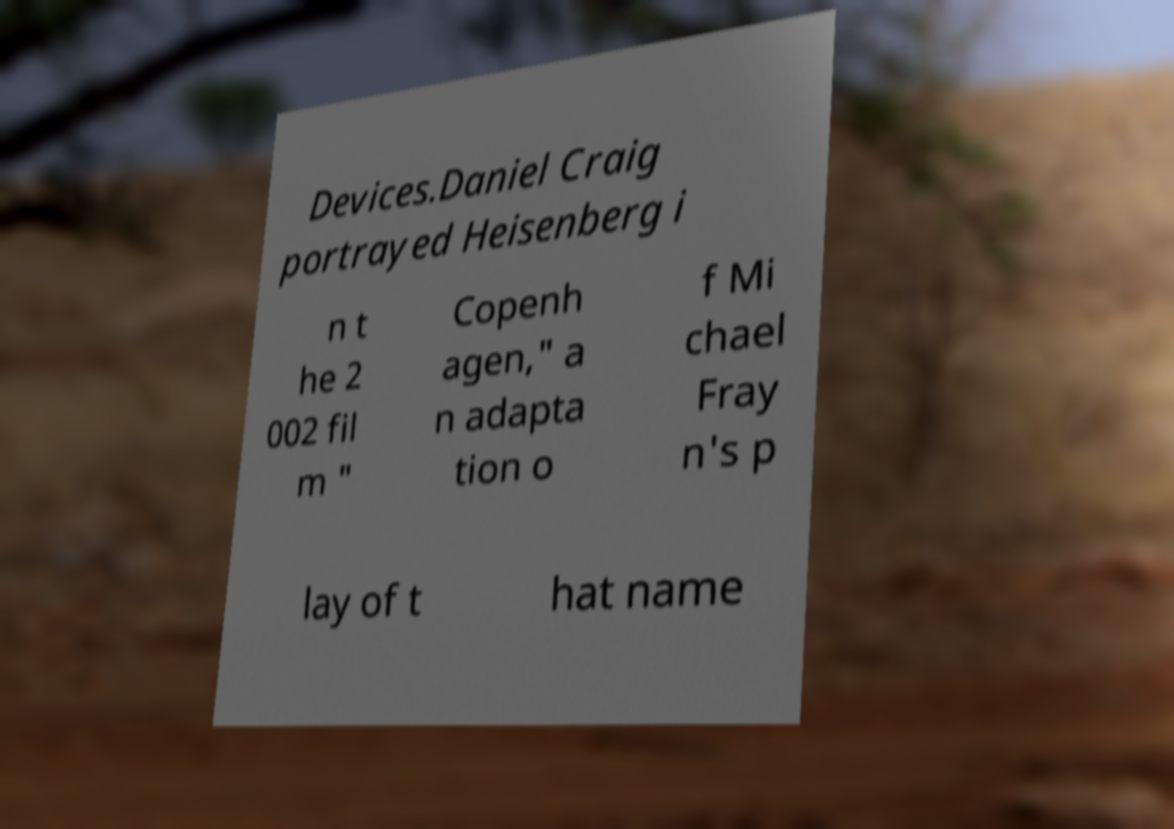Please read and relay the text visible in this image. What does it say? Devices.Daniel Craig portrayed Heisenberg i n t he 2 002 fil m " Copenh agen," a n adapta tion o f Mi chael Fray n's p lay of t hat name 